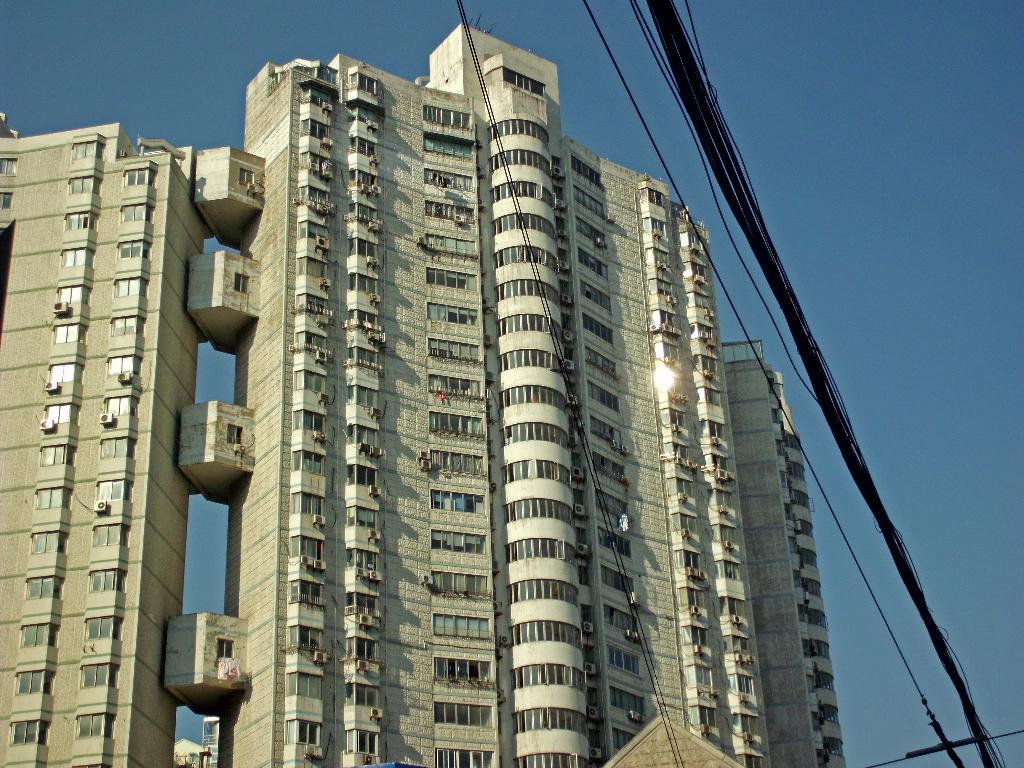What type of structure is the main subject of the image? There is a tower building in the picture. How many floors does the tower building have? The tower building has multiple floors. What else can be seen in the image besides the tower building? There are wires visible in the image. What is visible in the background of the image? The sky is visible in the background of the image. What is the color of the sky in the image? The sky is blue in color. How does the tower building compare to a camera in the image? There is no camera present in the image, so it cannot be compared to the tower building. 